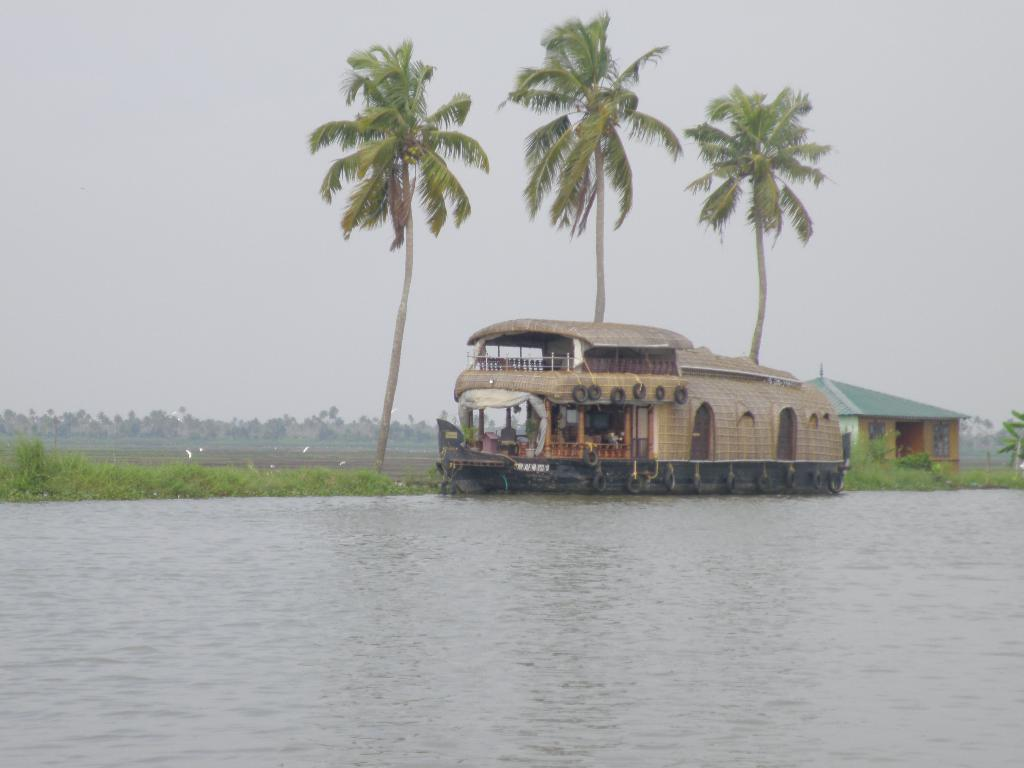What is the main feature of the image? The main feature of the image is water. What is on the water in the image? There is a boat on the water in the image. What type of vegetation can be seen in the image? Trees are visible in the image. What else is visible in the image besides the water and trees? The sky is visible in the image, as well as a house. What type of bread can be seen floating on the water in the image? There is no bread visible in the image; it only features water, a boat, trees, the sky, and a house. 